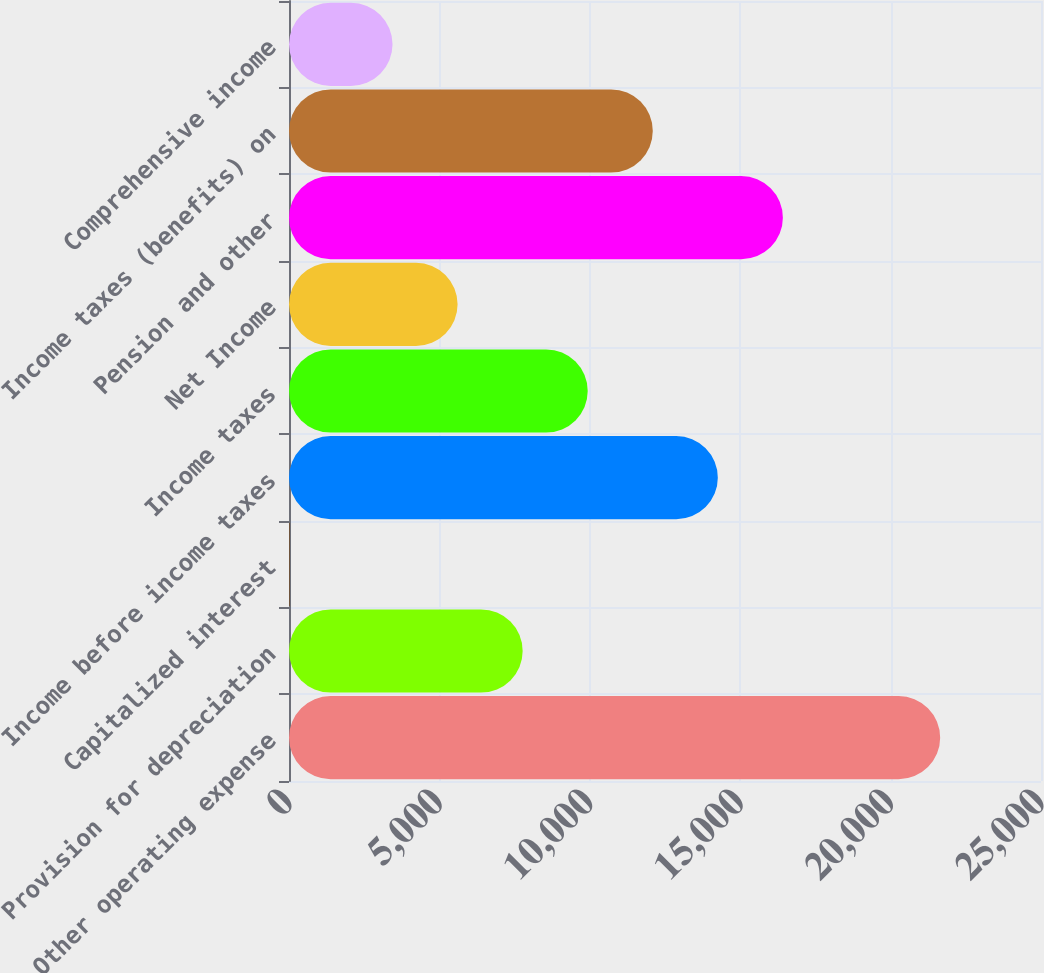Convert chart to OTSL. <chart><loc_0><loc_0><loc_500><loc_500><bar_chart><fcel>Other operating expense<fcel>Provision for depreciation<fcel>Capitalized interest<fcel>Income before income taxes<fcel>Income taxes<fcel>Net Income<fcel>Pension and other<fcel>Income taxes (benefits) on<fcel>Comprehensive income<nl><fcel>21648<fcel>7767.6<fcel>20<fcel>14256<fcel>9930.4<fcel>5604.8<fcel>16418.8<fcel>12093.2<fcel>3442<nl></chart> 